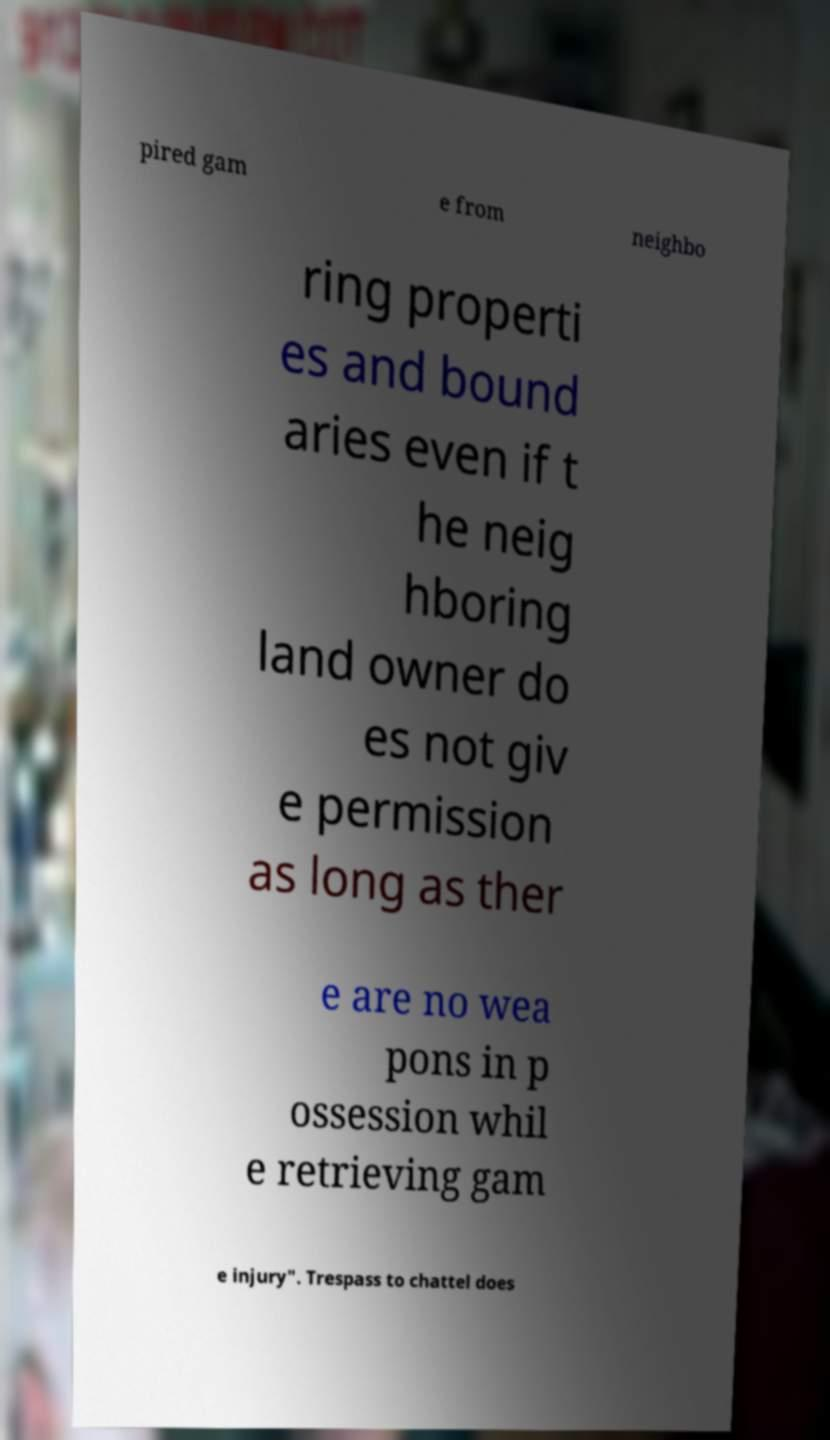There's text embedded in this image that I need extracted. Can you transcribe it verbatim? pired gam e from neighbo ring properti es and bound aries even if t he neig hboring land owner do es not giv e permission as long as ther e are no wea pons in p ossession whil e retrieving gam e injury". Trespass to chattel does 